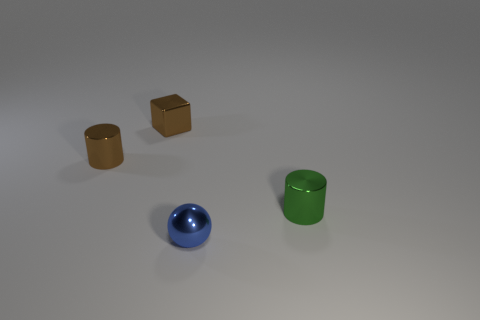Can you guess the possible size of these objects relative to each other? Based on their appearance in the image, we can infer the relative sizes of the objects to each other. The cubes seem to be uniform in size and they appear to be smaller in scale compared to the cylindrical objects, which suggests that these cylinders might be larger in both height and diameter. Without an explicit frame of reference, these estimations are based on perceived perspective and the positioning of objects within the image. 